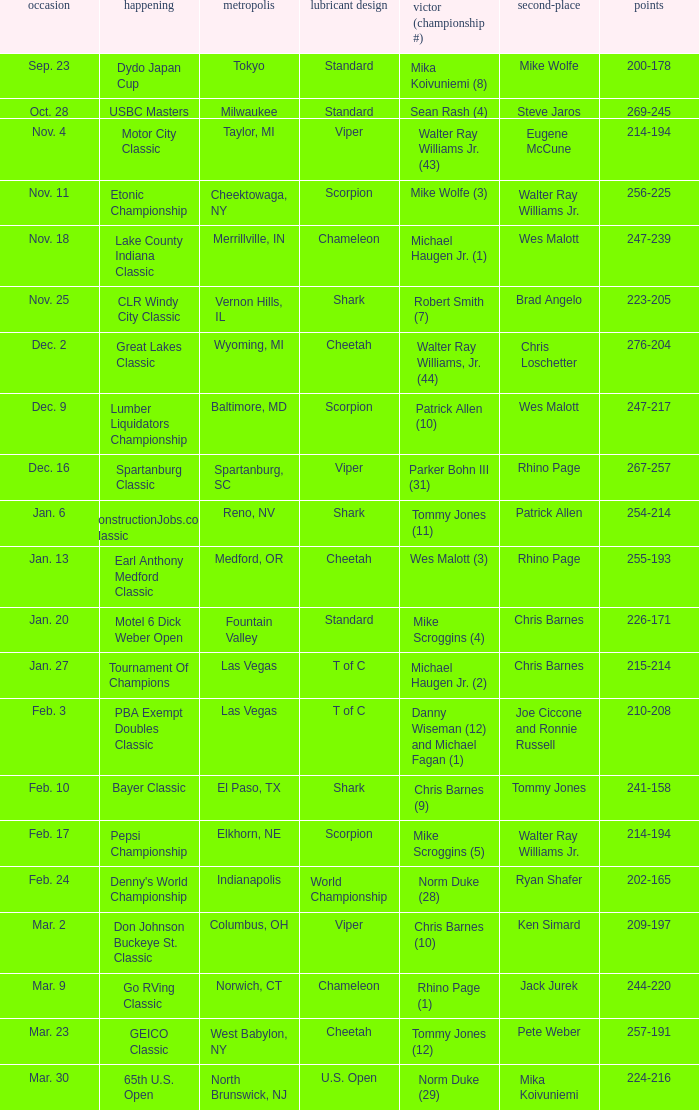Name the Date which has a Oil Pattern of chameleon, and a Event of lake county indiana classic? Nov. 18. 